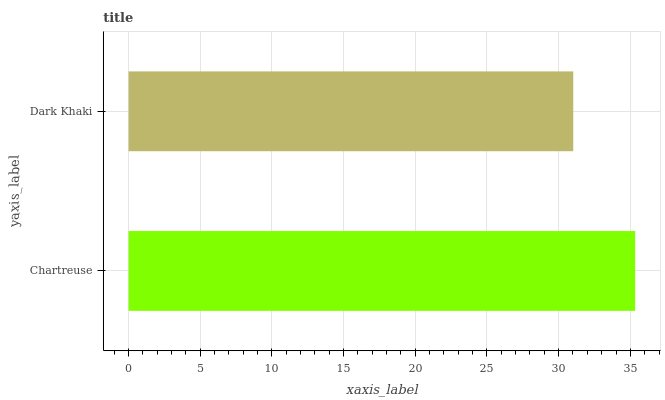Is Dark Khaki the minimum?
Answer yes or no. Yes. Is Chartreuse the maximum?
Answer yes or no. Yes. Is Dark Khaki the maximum?
Answer yes or no. No. Is Chartreuse greater than Dark Khaki?
Answer yes or no. Yes. Is Dark Khaki less than Chartreuse?
Answer yes or no. Yes. Is Dark Khaki greater than Chartreuse?
Answer yes or no. No. Is Chartreuse less than Dark Khaki?
Answer yes or no. No. Is Chartreuse the high median?
Answer yes or no. Yes. Is Dark Khaki the low median?
Answer yes or no. Yes. Is Dark Khaki the high median?
Answer yes or no. No. Is Chartreuse the low median?
Answer yes or no. No. 